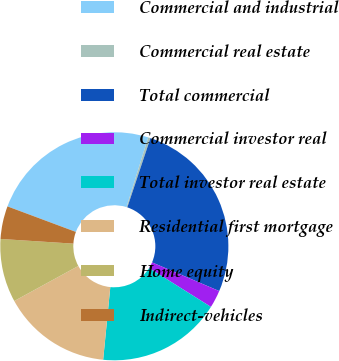Convert chart to OTSL. <chart><loc_0><loc_0><loc_500><loc_500><pie_chart><fcel>Commercial and industrial<fcel>Commercial real estate<fcel>Total commercial<fcel>Commercial investor real<fcel>Total investor real estate<fcel>Residential first mortgage<fcel>Home equity<fcel>Indirect-vehicles<nl><fcel>24.12%<fcel>0.33%<fcel>26.29%<fcel>2.5%<fcel>17.64%<fcel>15.47%<fcel>8.99%<fcel>4.66%<nl></chart> 